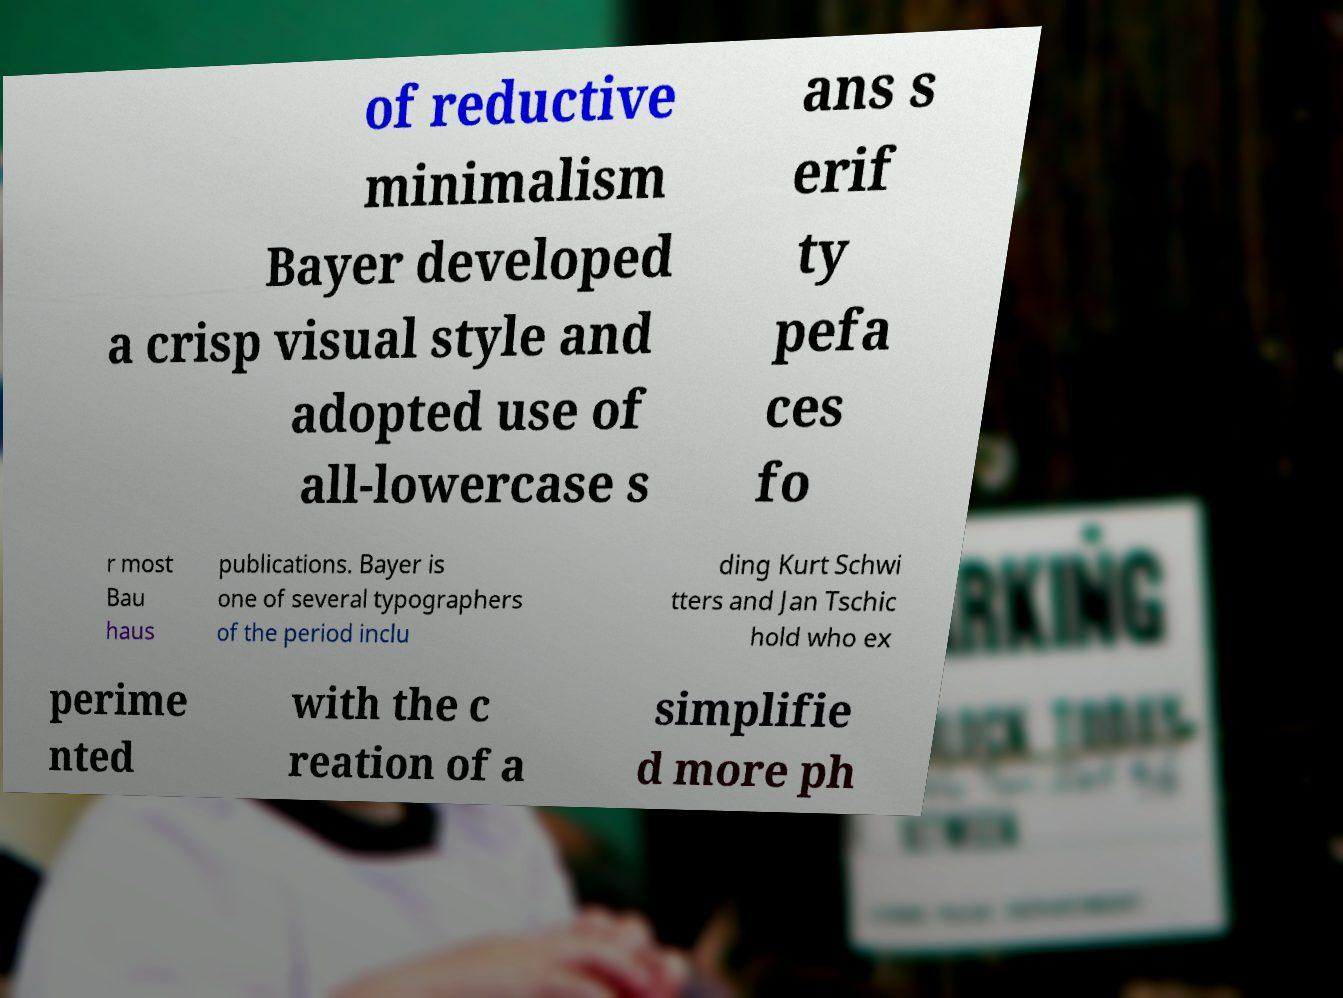Please identify and transcribe the text found in this image. of reductive minimalism Bayer developed a crisp visual style and adopted use of all-lowercase s ans s erif ty pefa ces fo r most Bau haus publications. Bayer is one of several typographers of the period inclu ding Kurt Schwi tters and Jan Tschic hold who ex perime nted with the c reation of a simplifie d more ph 